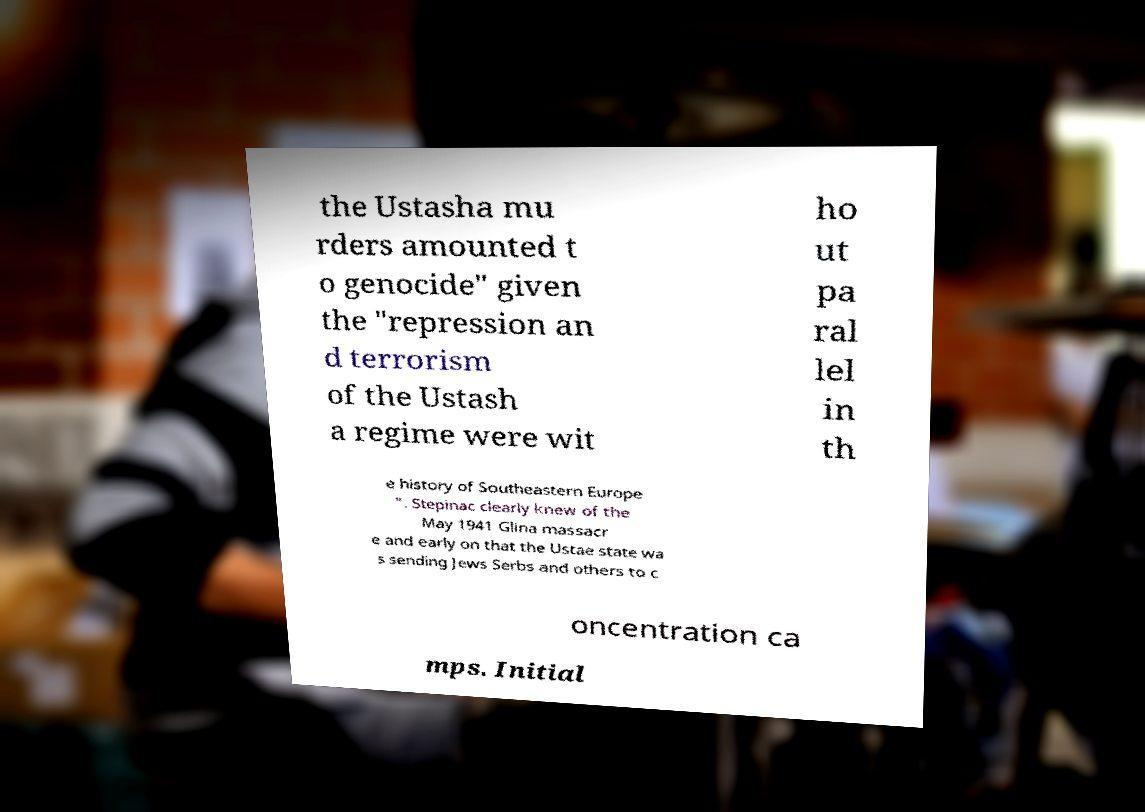Please identify and transcribe the text found in this image. the Ustasha mu rders amounted t o genocide" given the "repression an d terrorism of the Ustash a regime were wit ho ut pa ral lel in th e history of Southeastern Europe ". Stepinac clearly knew of the May 1941 Glina massacr e and early on that the Ustae state wa s sending Jews Serbs and others to c oncentration ca mps. Initial 